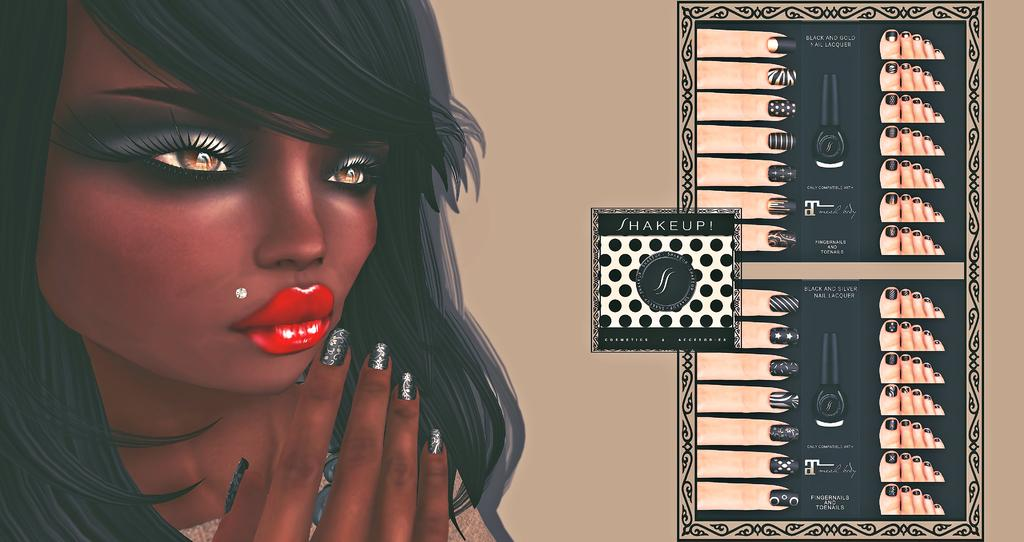What type of image is being described? The image is animated. Can you describe the characters or subjects in the image? There is a lady in the image. What else can be seen in the image besides the lady? There is a poster in the image. What is featured on the poster? The poster contains images and text. What year is depicted on the poster in the image? There is no specific year mentioned or depicted on the poster in the image. Can you describe the man in the image? There is no man present in the image; it features a lady and a poster. 